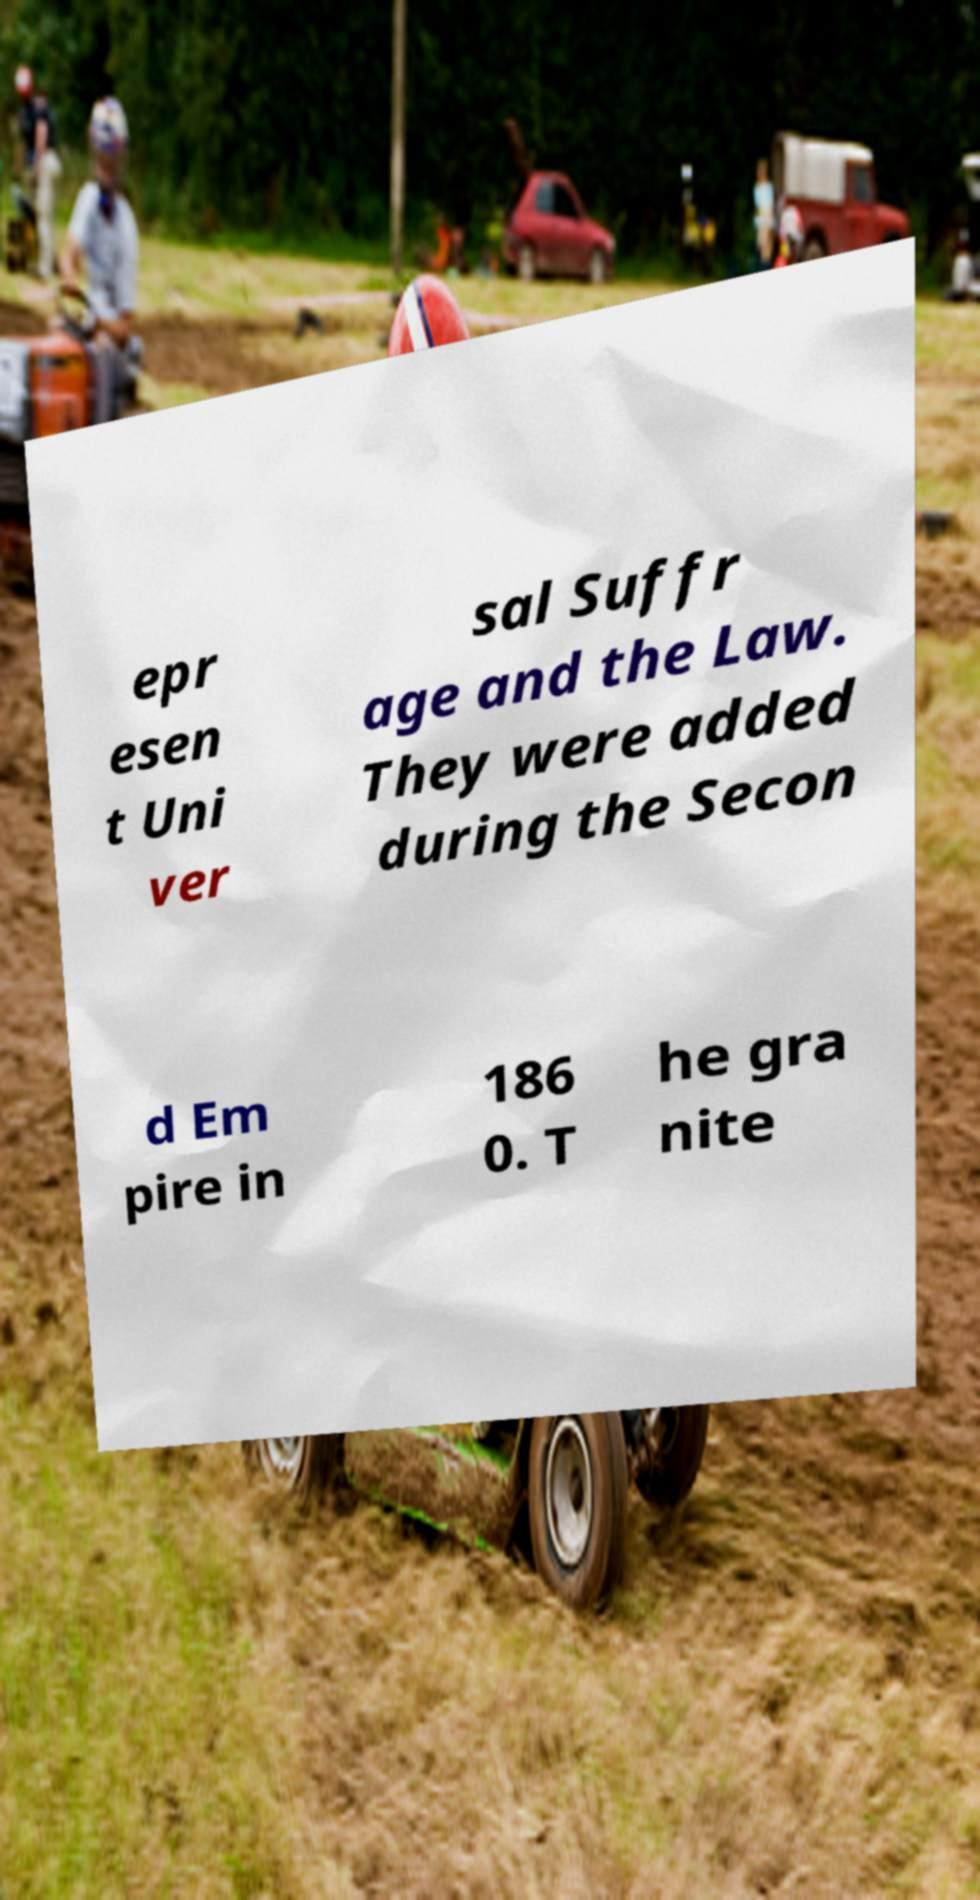Can you read and provide the text displayed in the image?This photo seems to have some interesting text. Can you extract and type it out for me? epr esen t Uni ver sal Suffr age and the Law. They were added during the Secon d Em pire in 186 0. T he gra nite 